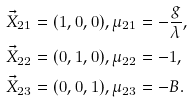<formula> <loc_0><loc_0><loc_500><loc_500>\vec { X } _ { 2 1 } & = ( 1 , 0 , 0 ) , \mu _ { 2 1 } = - \frac { g } { \lambda } , \\ \vec { X } _ { 2 2 } & = ( 0 , 1 , 0 ) , \mu _ { 2 2 } = - 1 , \\ \vec { X } _ { 2 3 } & = ( 0 , 0 , 1 ) , \mu _ { 2 3 } = - B .</formula> 